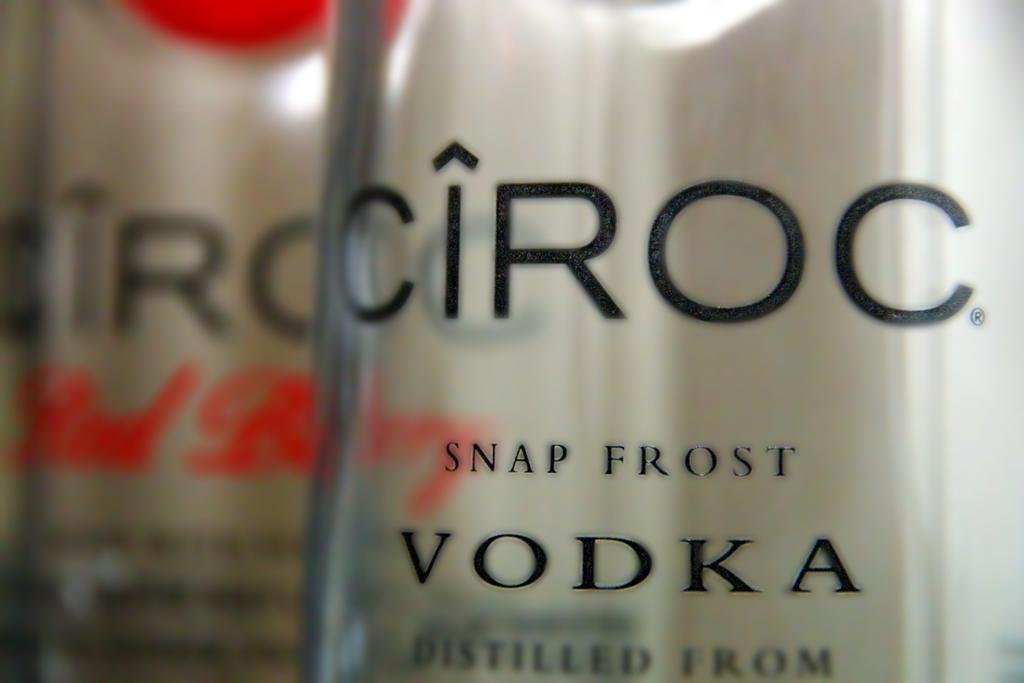What brand of vodka is this?
Your answer should be very brief. Ciroc. What kind of frost is this vodka?
Your response must be concise. Snap. 